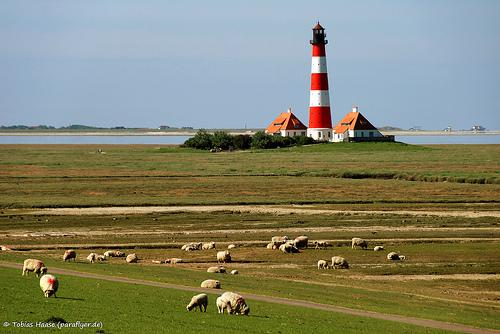Question: what color is the buildings roof?
Choices:
A. Brown.
B. Black.
C. Gray.
D. White.
Answer with the letter. Answer: A Question: what is growing out of the ground?
Choices:
A. Flowers.
B. Plants and grass.
C. Trees.
D. Weeds.
Answer with the letter. Answer: B Question: where are the animals?
Choices:
A. In the sky.
B. In the zoo.
C. In the water.
D. On the field.
Answer with the letter. Answer: D Question: what is the lighthouse between?
Choices:
A. Two buildings.
B. Two rocks.
C. A Dock and a ship.
D. Two trees.
Answer with the letter. Answer: A Question: how many bodies of water are there?
Choices:
A. 1.
B. 2.
C. 3.
D. 4.
Answer with the letter. Answer: A 